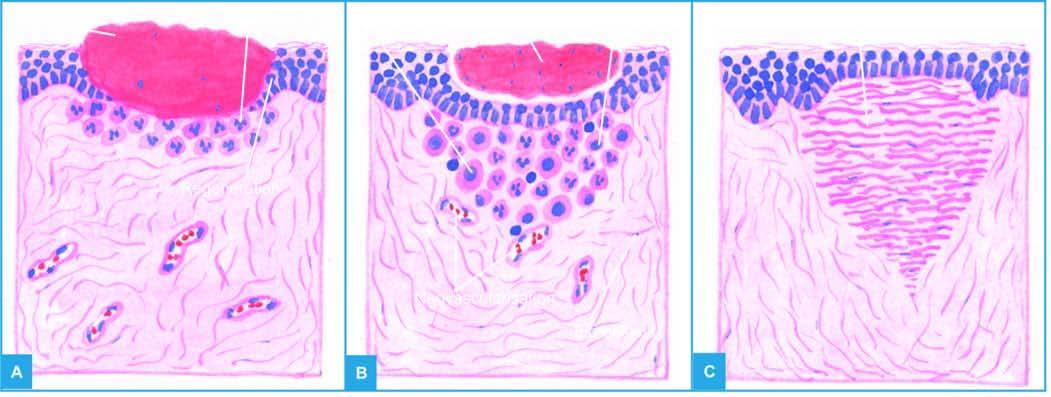do epithelial spurs from the margins of wound meet in the middle to cover the gap and separate the underlying viable tissue from necrotic tissue at the surface forming scab?
Answer the question using a single word or phrase. Yes 